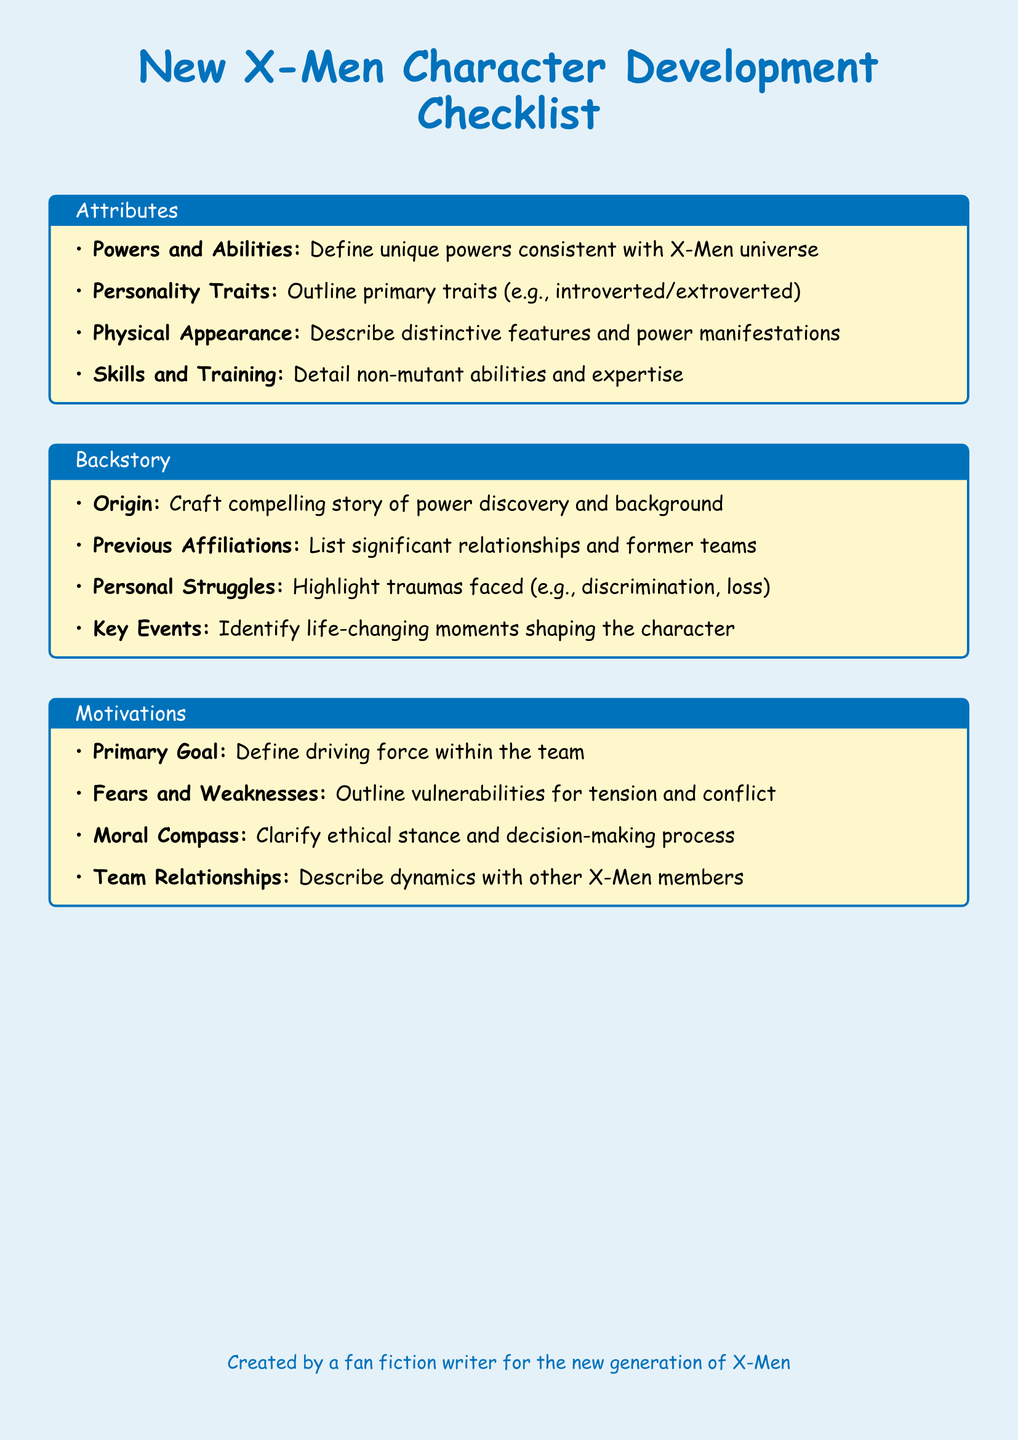What is the purpose of the checklist? The checklist is designed for character development focused on the new generation of X-Men, including attributes, backstory, and motivations.
Answer: Character development How many sections are in the checklist? There are three sections in the checklist: Attributes, Backstory, and Motivations.
Answer: Three What trait is listed under Personality Traits? A primary personality trait that can be outlined is either introverted or extroverted.
Answer: Introverted or extroverted What is the focus of the Primary Goal? The Primary Goal defines the driving force within the X-Men team for the character being developed.
Answer: Driving force What does the Backstory section require for Origin? The Origin requires crafting a compelling story of power discovery and character background.
Answer: Compelling story What is a key component of Personal Struggles? Personal Struggles should highlight traumas such as discrimination or loss.
Answer: Discrimination or loss What should be described in the Team Relationships? Team Relationships require describing dynamics with other X-Men members.
Answer: Dynamics with other members What is mentioned under Skills and Training? Skills and Training detail non-mutant abilities and expertise.
Answer: Non-mutant abilities and expertise What does the Moral Compass clarify? The Moral Compass clarifies the character's ethical stance and decision-making process.
Answer: Ethical stance 